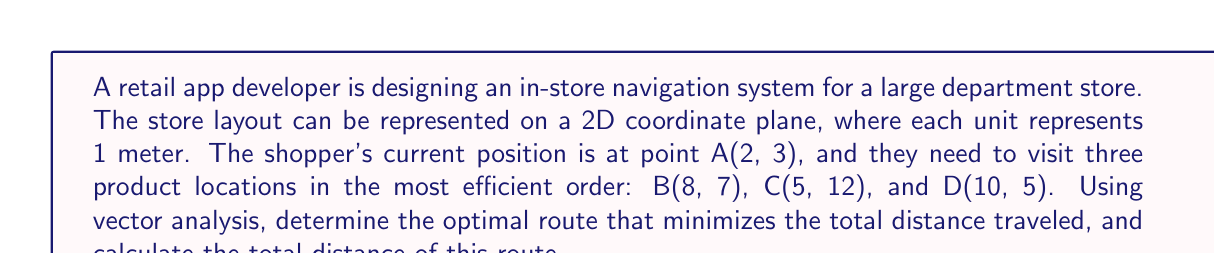Could you help me with this problem? To solve this problem, we'll use vector analysis to determine the most efficient route:

1. First, let's represent each location as a vector from the origin:
   $$\vec{A} = \begin{pmatrix} 2 \\ 3 \end{pmatrix}, \vec{B} = \begin{pmatrix} 8 \\ 7 \end{pmatrix}, \vec{C} = \begin{pmatrix} 5 \\ 12 \end{pmatrix}, \vec{D} = \begin{pmatrix} 10 \\ 5 \end{pmatrix}$$

2. Calculate the vectors between all points:
   $$\vec{AB} = \vec{B} - \vec{A} = \begin{pmatrix} 6 \\ 4 \end{pmatrix}$$
   $$\vec{AC} = \vec{C} - \vec{A} = \begin{pmatrix} 3 \\ 9 \end{pmatrix}$$
   $$\vec{AD} = \vec{D} - \vec{A} = \begin{pmatrix} 8 \\ 2 \end{pmatrix}$$
   $$\vec{BC} = \vec{C} - \vec{B} = \begin{pmatrix} -3 \\ 5 \end{pmatrix}$$
   $$\vec{BD} = \vec{D} - \vec{B} = \begin{pmatrix} 2 \\ -2 \end{pmatrix}$$
   $$\vec{CD} = \vec{D} - \vec{C} = \begin{pmatrix} 5 \\ -7 \end{pmatrix}$$

3. Calculate the magnitude (distance) of each vector:
   $$|\vec{AB}| = \sqrt{6^2 + 4^2} = \sqrt{52} \approx 7.21$$
   $$|\vec{AC}| = \sqrt{3^2 + 9^2} = \sqrt{90} \approx 9.49$$
   $$|\vec{AD}| = \sqrt{8^2 + 2^2} = \sqrt{68} \approx 8.25$$
   $$|\vec{BC}| = \sqrt{(-3)^2 + 5^2} = \sqrt{34} \approx 5.83$$
   $$|\vec{BD}| = \sqrt{2^2 + (-2)^2} = \sqrt{8} \approx 2.83$$
   $$|\vec{CD}| = \sqrt{5^2 + (-7)^2} = \sqrt{74} \approx 8.60$$

4. To find the most efficient route, we need to consider all possible paths:
   A → B → C → D
   A → B → D → C
   A → C → B → D
   A → C → D → B
   A → D → B → C
   A → D → C → B

5. Calculate the total distance for each path:
   A → B → C → D: 7.21 + 5.83 + 8.60 = 21.64
   A → B → D → C: 7.21 + 2.83 + 8.60 = 18.64
   A → C → B → D: 9.49 + 5.83 + 2.83 = 18.15
   A → C → D → B: 9.49 + 8.60 + 2.83 = 20.92
   A → D → B → C: 8.25 + 2.83 + 5.83 = 16.91
   A → D → C → B: 8.25 + 8.60 + 5.83 = 22.68

6. The shortest path is A → D → B → C, with a total distance of 16.91 meters.

[asy]
unitsize(0.5cm);
draw((-1,-1)--(12,14),gray);
dot((2,3)); label("A",(2,3),SW);
dot((8,7)); label("B",(8,7),SE);
dot((5,12)); label("C",(5,12),N);
dot((10,5)); label("D",(10,5),E);
draw((2,3)--(10,5)--(8,7)--(5,12),red,Arrow);
[/asy]
Answer: The optimal route is A → D → B → C, with a total distance of approximately 16.91 meters. 